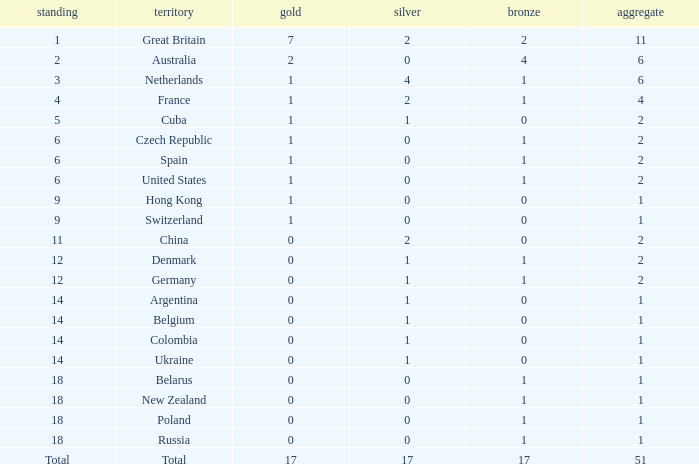Tell me the rank for bronze less than 17 and gold less than 1 11.0. 